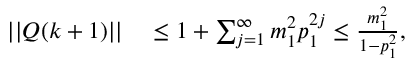Convert formula to latex. <formula><loc_0><loc_0><loc_500><loc_500>\begin{array} { r l } { | | Q ( k + 1 ) | | } & \leq 1 + \sum _ { j = 1 } ^ { \infty } m _ { 1 } ^ { 2 } p _ { 1 } ^ { 2 j } \leq \frac { m _ { 1 } ^ { 2 } } { 1 - p _ { 1 } ^ { 2 } } , } \end{array}</formula> 